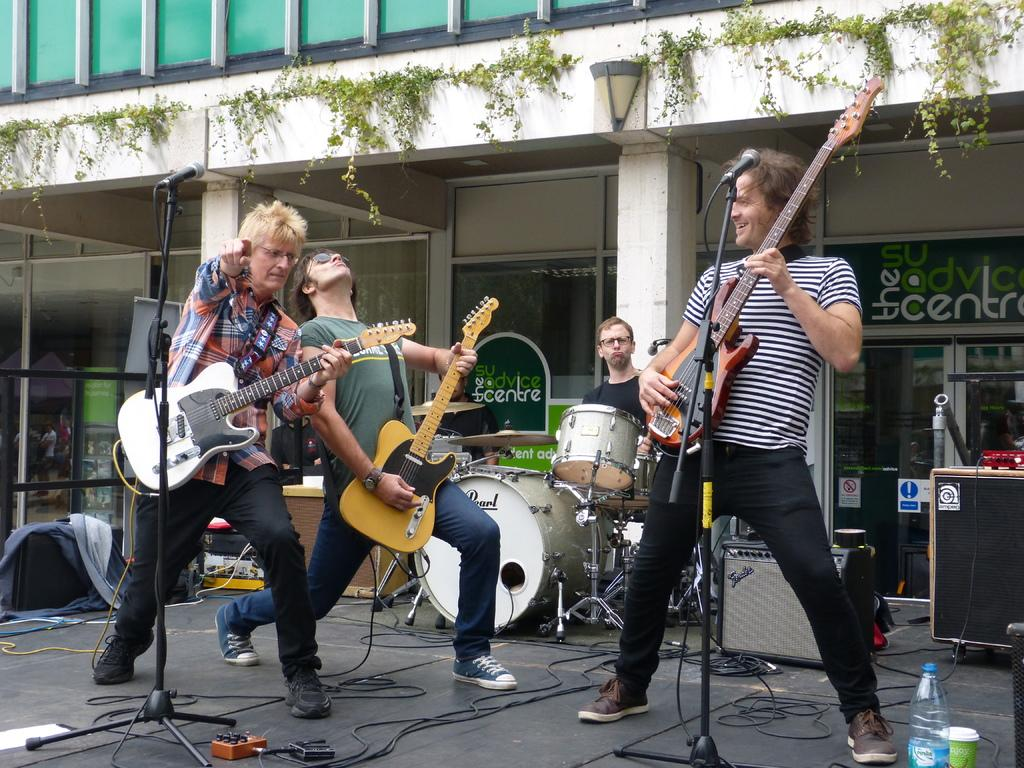What is happening on the stage in the image? There are people on the stage, and they are performing. What are the people on the stage doing? They are playing musical instruments. What can be seen in the background of the image? There is a building, a plant, and light visible in the background. How many letters are being passed between the women on the stage? There is no mention of women or letters in the image; the people on the stage are playing musical instruments. 